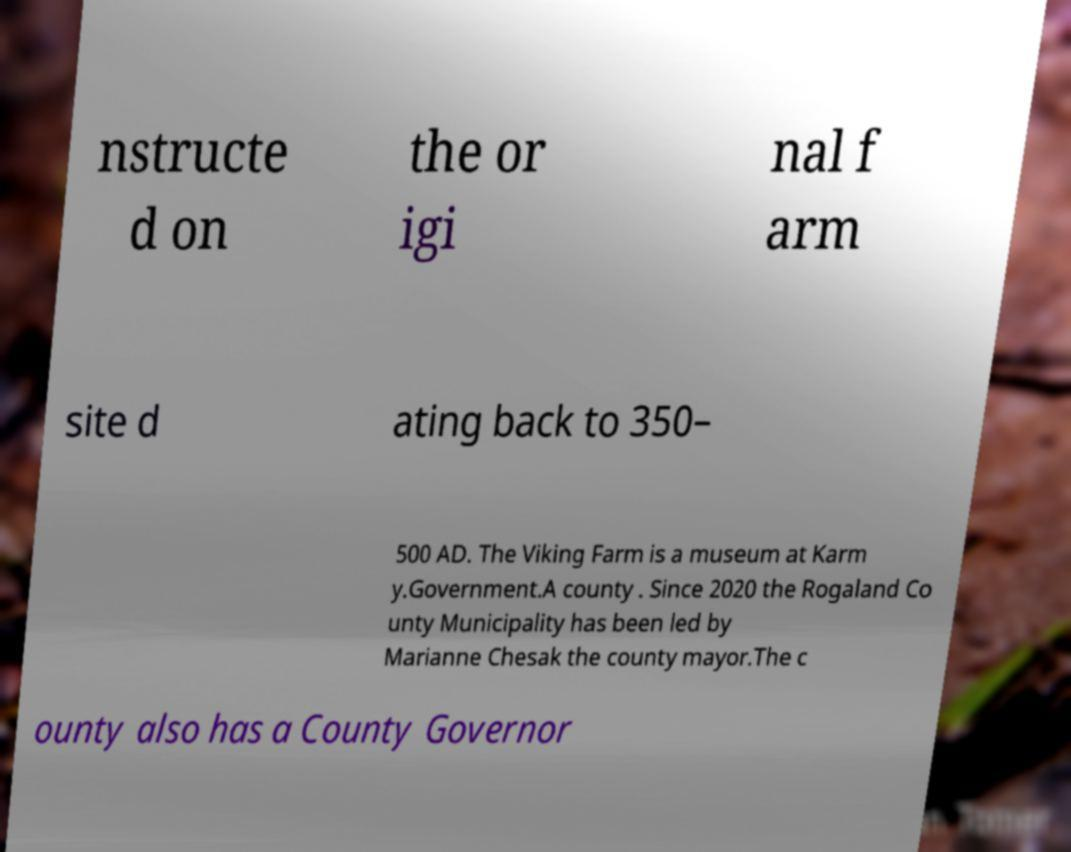Can you read and provide the text displayed in the image?This photo seems to have some interesting text. Can you extract and type it out for me? nstructe d on the or igi nal f arm site d ating back to 350– 500 AD. The Viking Farm is a museum at Karm y.Government.A county . Since 2020 the Rogaland Co unty Municipality has been led by Marianne Chesak the county mayor.The c ounty also has a County Governor 